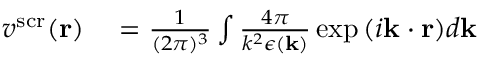<formula> <loc_0><loc_0><loc_500><loc_500>\begin{array} { r l } { v ^ { s c r } ( r ) } & = \frac { 1 } { ( 2 \pi ) ^ { 3 } } \int \frac { 4 \pi } { k ^ { 2 } \epsilon ( k ) } \exp { ( i k \cdot r ) } d k } \end{array}</formula> 